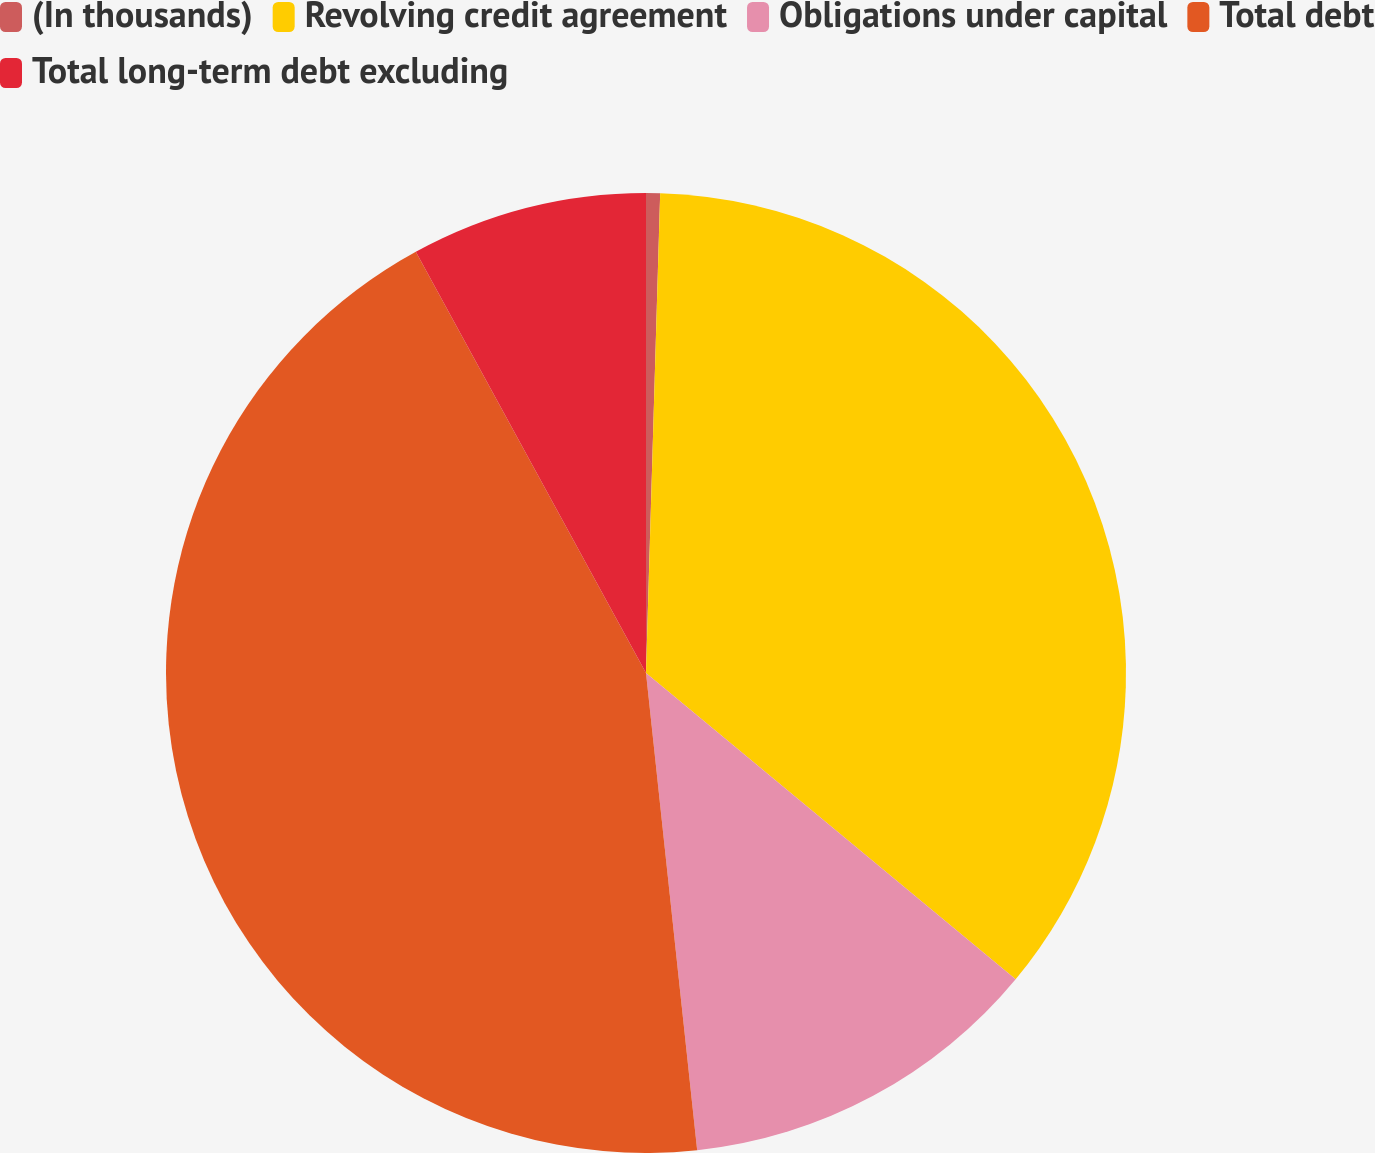<chart> <loc_0><loc_0><loc_500><loc_500><pie_chart><fcel>(In thousands)<fcel>Revolving credit agreement<fcel>Obligations under capital<fcel>Total debt<fcel>Total long-term debt excluding<nl><fcel>0.47%<fcel>35.54%<fcel>12.29%<fcel>43.74%<fcel>7.96%<nl></chart> 